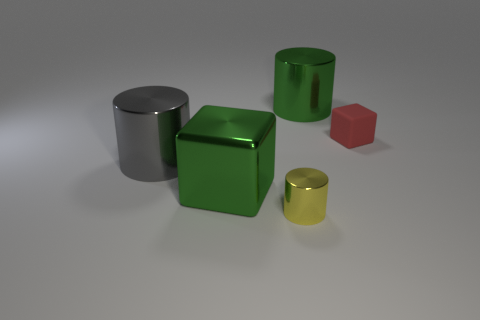There is a green block that is the same size as the gray metal object; what is it made of?
Offer a terse response. Metal. Is the number of shiny cylinders that are right of the big gray object less than the number of cylinders?
Ensure brevity in your answer.  Yes. What is the shape of the large green metal thing that is behind the red block that is on the right side of the large green thing that is in front of the red matte cube?
Your answer should be very brief. Cylinder. There is a shiny cylinder that is in front of the green shiny block; what size is it?
Keep it short and to the point. Small. There is a gray metallic object that is the same size as the green cube; what is its shape?
Keep it short and to the point. Cylinder. How many objects are small cubes or gray cylinders to the left of the yellow shiny object?
Make the answer very short. 2. There is a large green object that is in front of the large cylinder that is to the right of the gray cylinder; how many tiny metal objects are behind it?
Keep it short and to the point. 0. What is the color of the block that is the same material as the big green cylinder?
Provide a short and direct response. Green. Does the cylinder in front of the gray object have the same size as the small red cube?
Provide a succinct answer. Yes. What number of things are gray things or tiny cyan things?
Your answer should be compact. 1. 